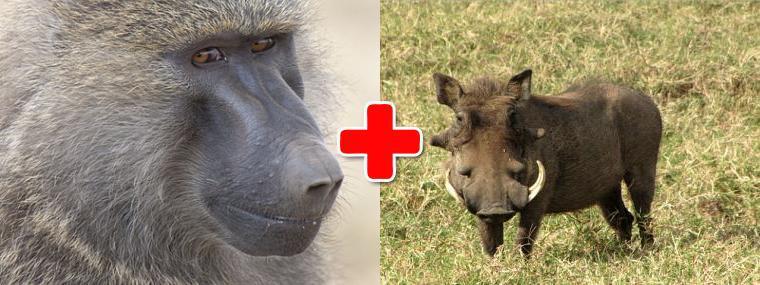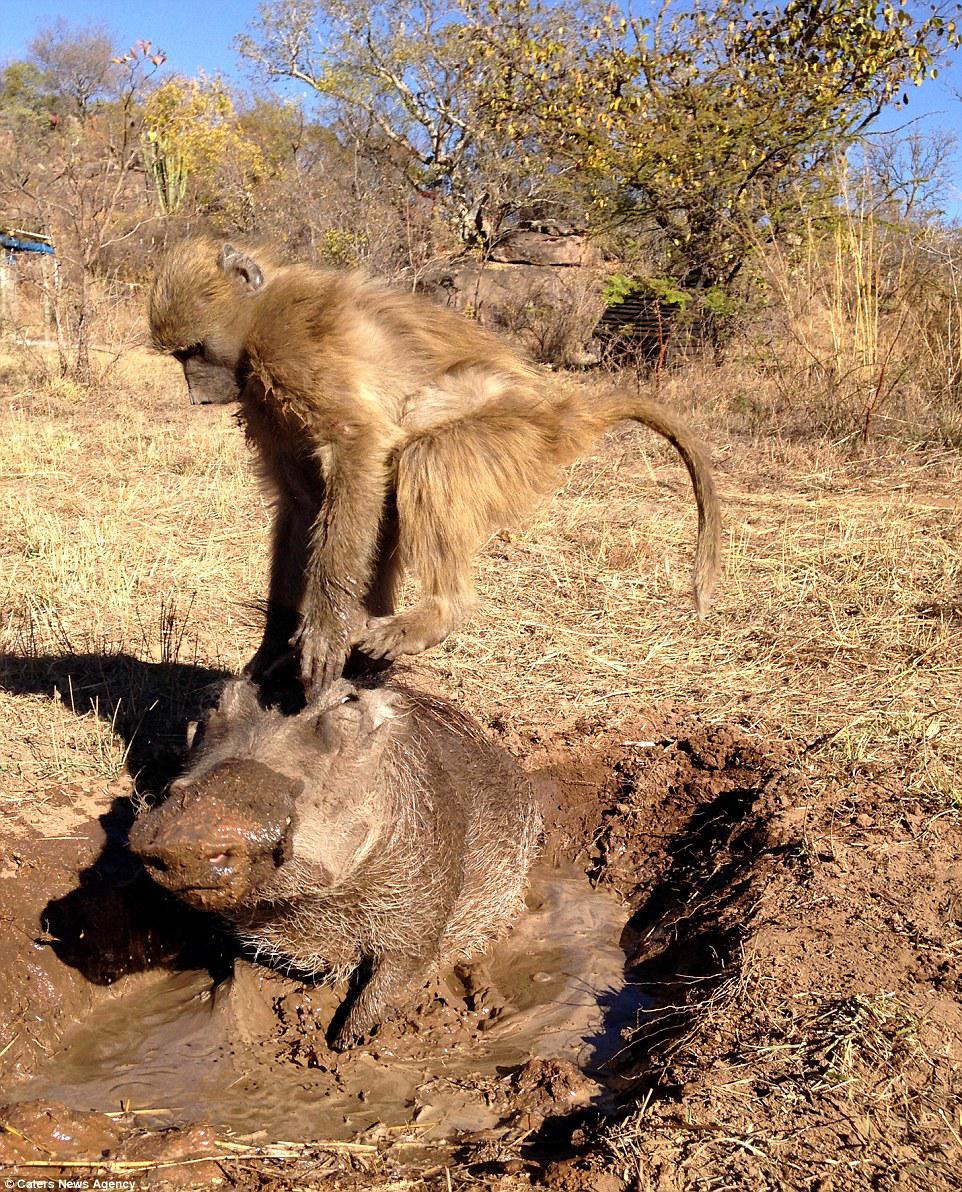The first image is the image on the left, the second image is the image on the right. Considering the images on both sides, is "The right image has a monkey interacting with a warthog." valid? Answer yes or no. Yes. The first image is the image on the left, the second image is the image on the right. Analyze the images presented: Is the assertion "At least one photo contains a monkey on top of a warthog." valid? Answer yes or no. Yes. 